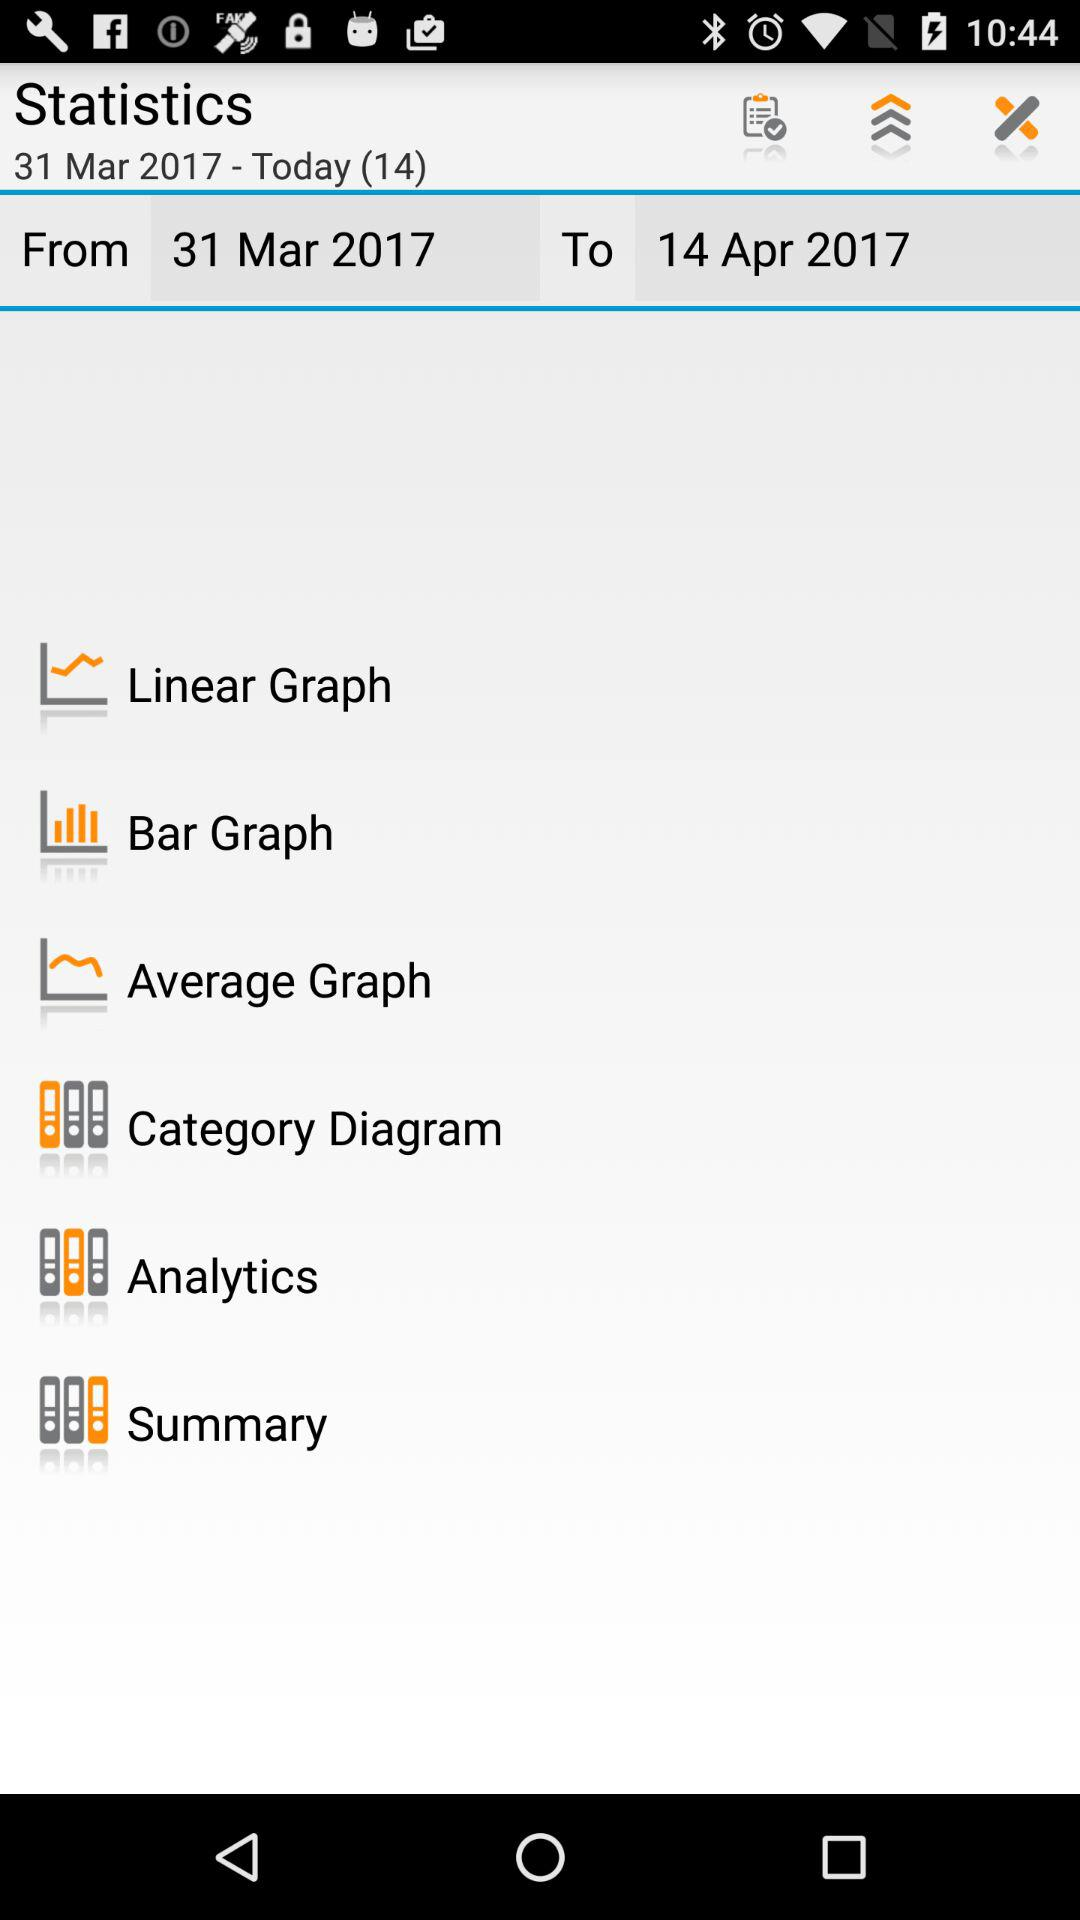What is the selected date range? The selected date range is from March 31, 2017 to April 14, 2017. 